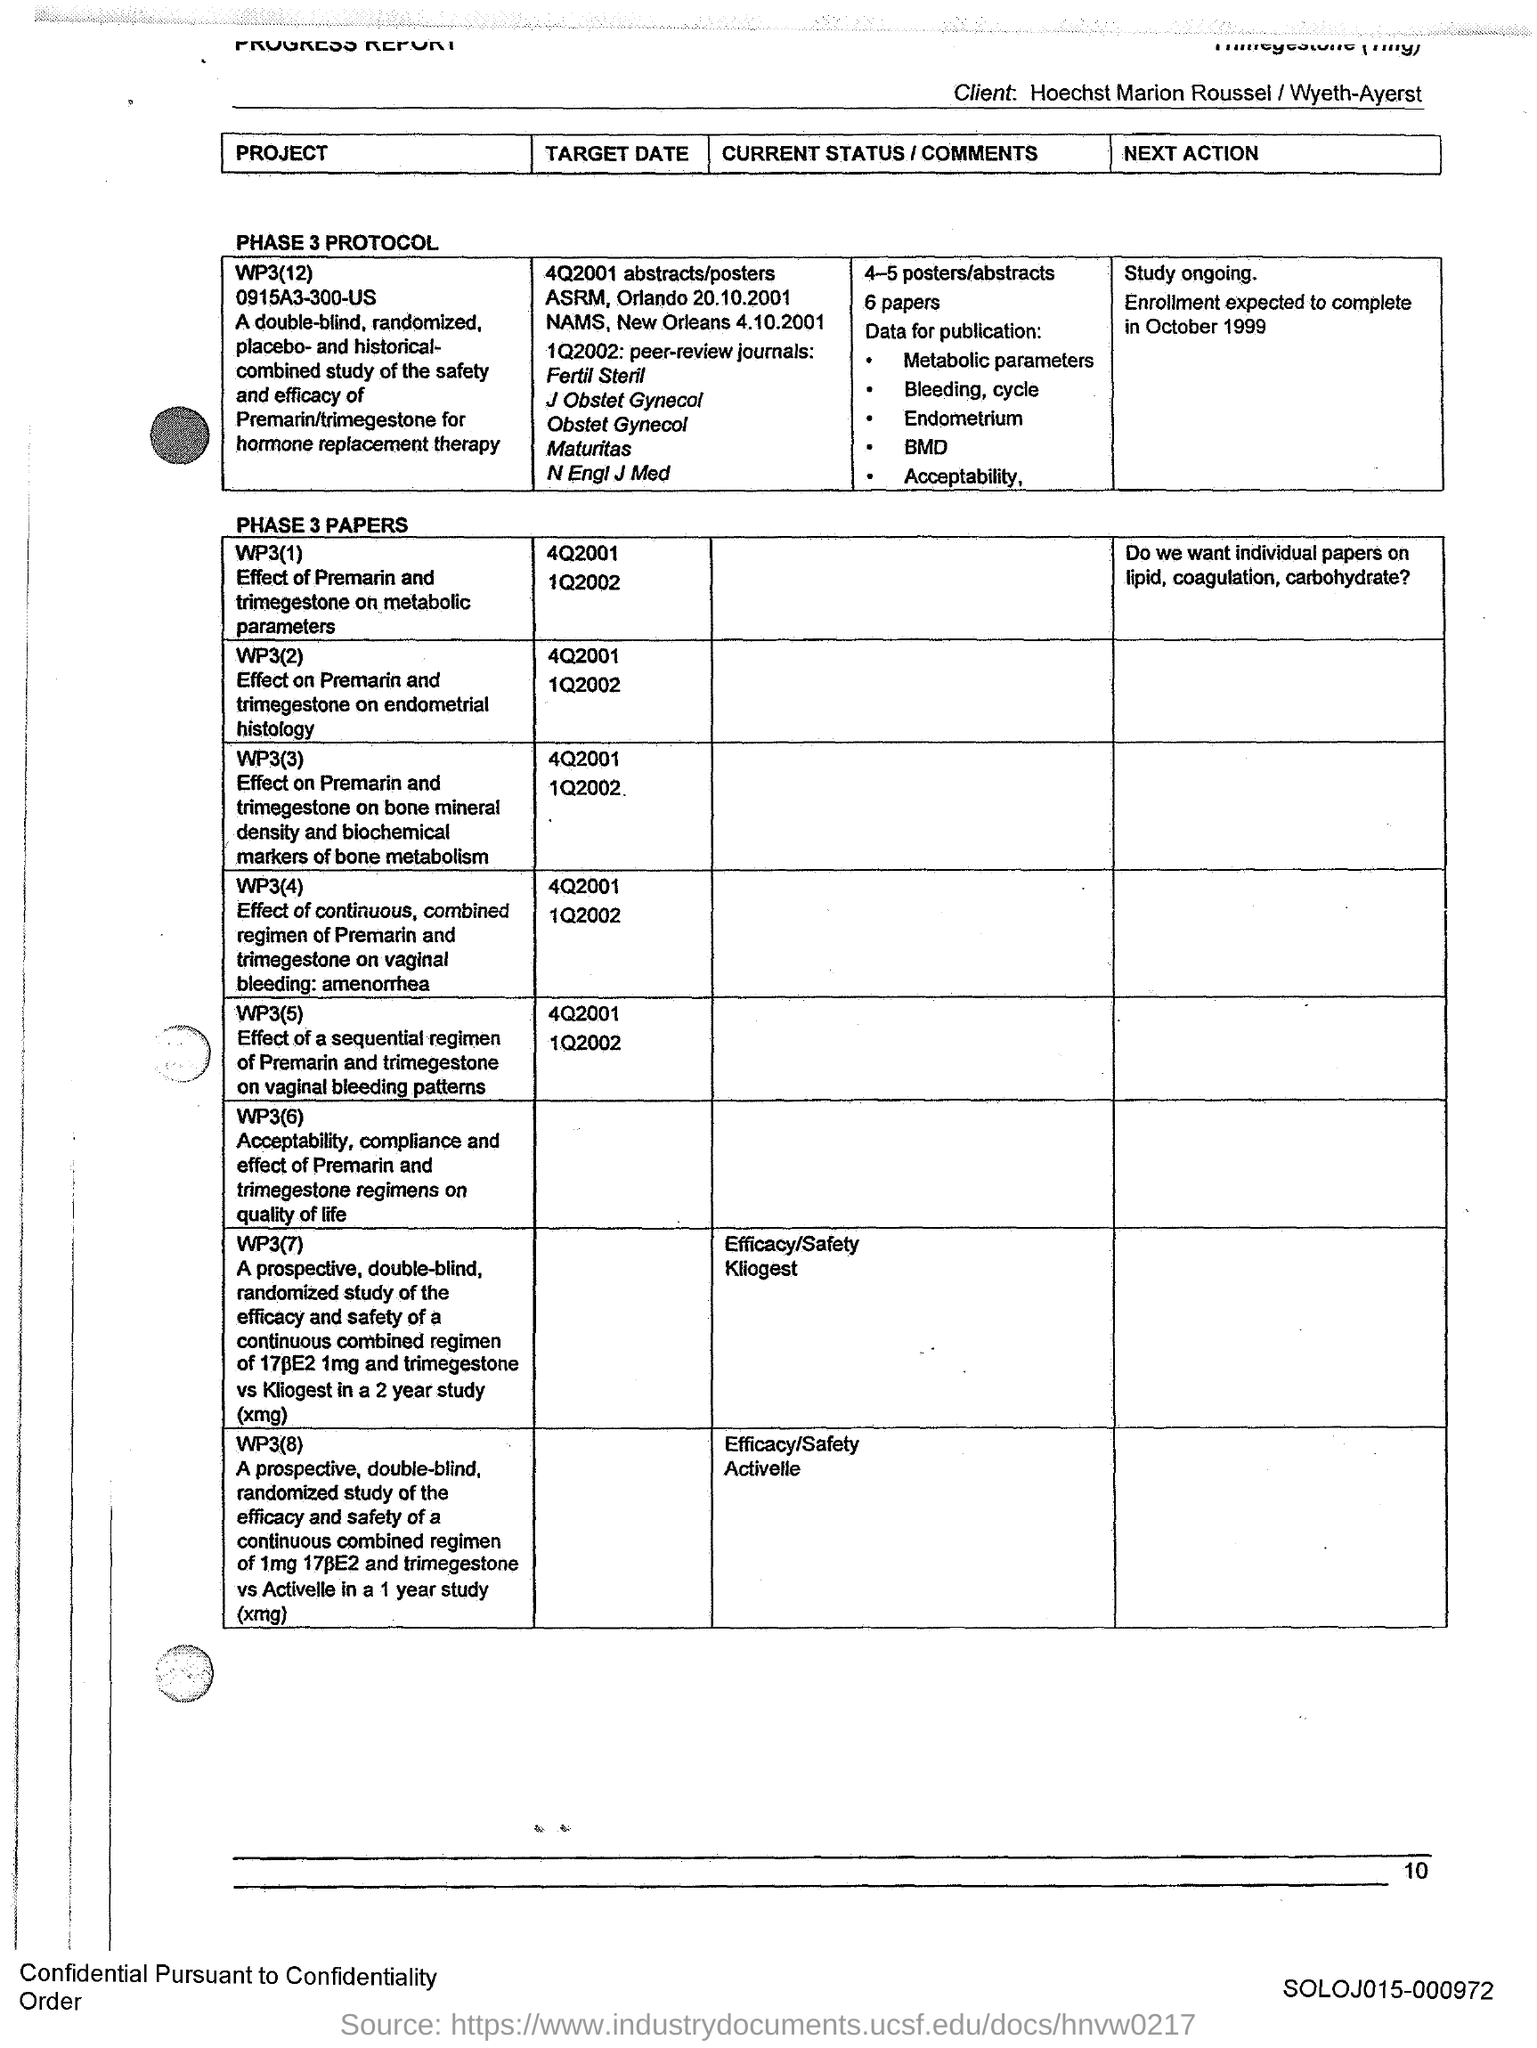What is the paper WP3(2) about?
Ensure brevity in your answer.  Effect on Premarin and Trimegestone on endometrial histology. What is the code mentioned at the bottom of the page?
Provide a succinct answer. SOLOJ015-000972. 